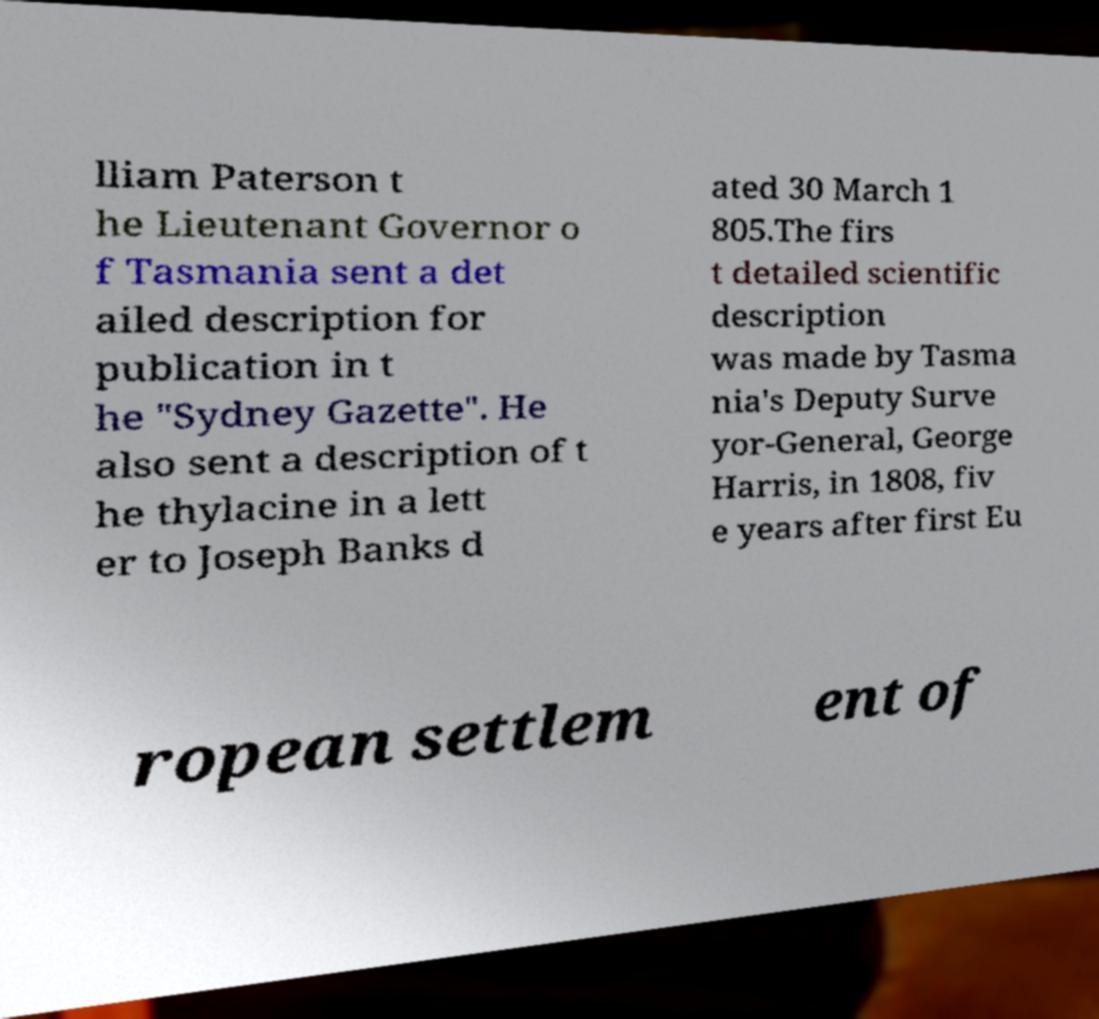Can you read and provide the text displayed in the image?This photo seems to have some interesting text. Can you extract and type it out for me? lliam Paterson t he Lieutenant Governor o f Tasmania sent a det ailed description for publication in t he "Sydney Gazette". He also sent a description of t he thylacine in a lett er to Joseph Banks d ated 30 March 1 805.The firs t detailed scientific description was made by Tasma nia's Deputy Surve yor-General, George Harris, in 1808, fiv e years after first Eu ropean settlem ent of 